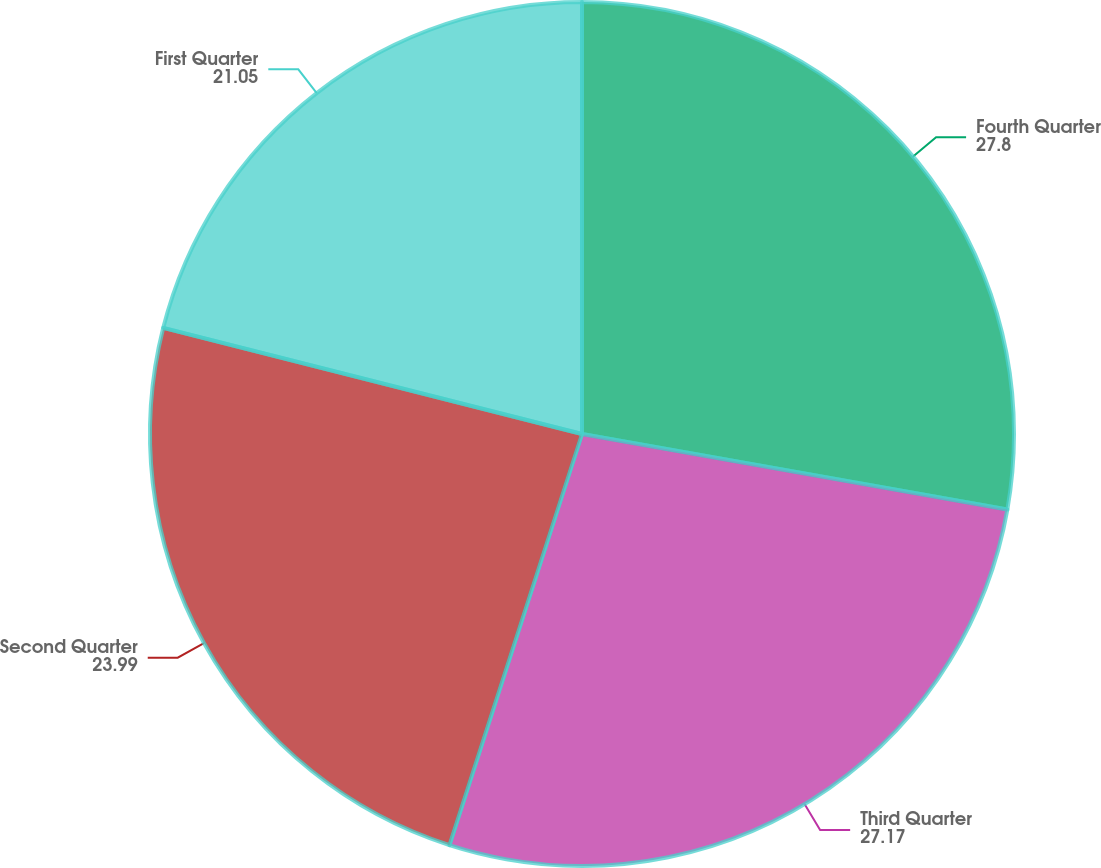<chart> <loc_0><loc_0><loc_500><loc_500><pie_chart><fcel>Fourth Quarter<fcel>Third Quarter<fcel>Second Quarter<fcel>First Quarter<nl><fcel>27.8%<fcel>27.17%<fcel>23.99%<fcel>21.05%<nl></chart> 